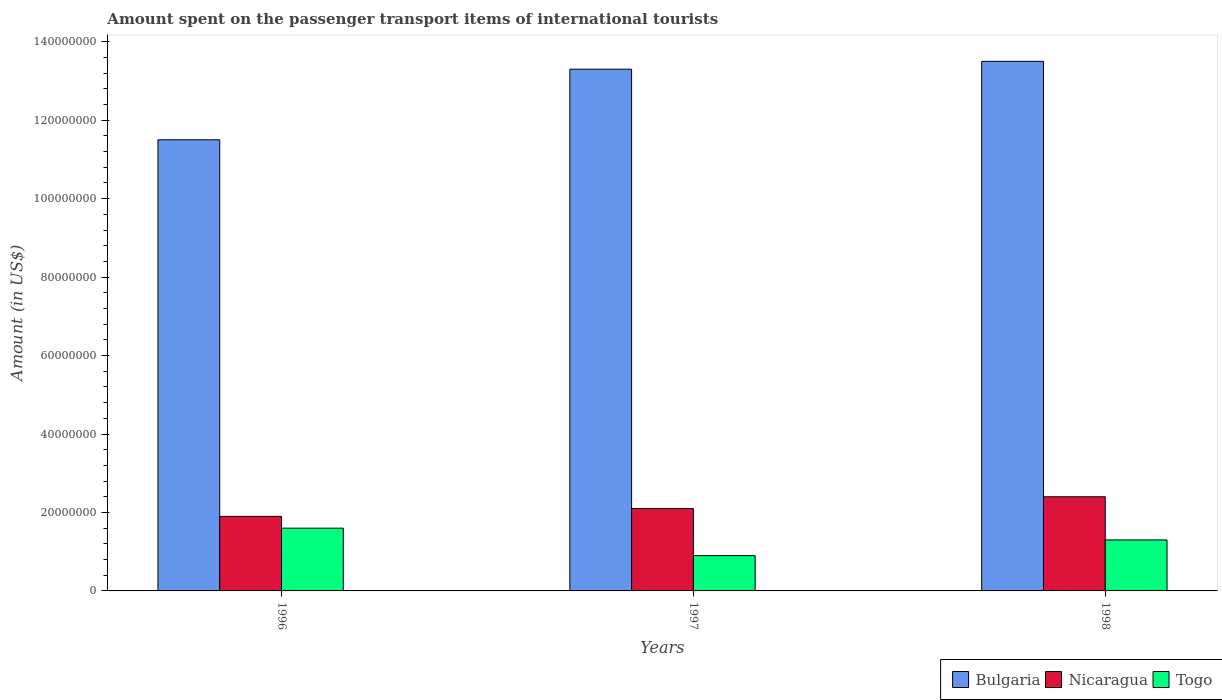How many different coloured bars are there?
Your answer should be very brief. 3. How many groups of bars are there?
Offer a terse response. 3. Are the number of bars per tick equal to the number of legend labels?
Offer a terse response. Yes. Are the number of bars on each tick of the X-axis equal?
Make the answer very short. Yes. In how many cases, is the number of bars for a given year not equal to the number of legend labels?
Your answer should be compact. 0. What is the amount spent on the passenger transport items of international tourists in Bulgaria in 1996?
Your answer should be very brief. 1.15e+08. Across all years, what is the maximum amount spent on the passenger transport items of international tourists in Nicaragua?
Provide a short and direct response. 2.40e+07. Across all years, what is the minimum amount spent on the passenger transport items of international tourists in Togo?
Your response must be concise. 9.00e+06. In which year was the amount spent on the passenger transport items of international tourists in Nicaragua minimum?
Offer a very short reply. 1996. What is the total amount spent on the passenger transport items of international tourists in Nicaragua in the graph?
Your answer should be compact. 6.40e+07. What is the difference between the amount spent on the passenger transport items of international tourists in Bulgaria in 1996 and that in 1998?
Provide a succinct answer. -2.00e+07. What is the difference between the amount spent on the passenger transport items of international tourists in Togo in 1998 and the amount spent on the passenger transport items of international tourists in Nicaragua in 1996?
Your response must be concise. -6.00e+06. What is the average amount spent on the passenger transport items of international tourists in Togo per year?
Offer a terse response. 1.27e+07. In the year 1998, what is the difference between the amount spent on the passenger transport items of international tourists in Bulgaria and amount spent on the passenger transport items of international tourists in Togo?
Offer a very short reply. 1.22e+08. In how many years, is the amount spent on the passenger transport items of international tourists in Togo greater than 128000000 US$?
Offer a terse response. 0. What is the ratio of the amount spent on the passenger transport items of international tourists in Nicaragua in 1996 to that in 1998?
Give a very brief answer. 0.79. What is the difference between the highest and the second highest amount spent on the passenger transport items of international tourists in Nicaragua?
Provide a succinct answer. 3.00e+06. What is the difference between the highest and the lowest amount spent on the passenger transport items of international tourists in Nicaragua?
Your answer should be very brief. 5.00e+06. What does the 1st bar from the left in 1998 represents?
Provide a succinct answer. Bulgaria. What does the 2nd bar from the right in 1996 represents?
Your answer should be compact. Nicaragua. Is it the case that in every year, the sum of the amount spent on the passenger transport items of international tourists in Nicaragua and amount spent on the passenger transport items of international tourists in Togo is greater than the amount spent on the passenger transport items of international tourists in Bulgaria?
Make the answer very short. No. Are all the bars in the graph horizontal?
Ensure brevity in your answer.  No. What is the difference between two consecutive major ticks on the Y-axis?
Offer a terse response. 2.00e+07. Where does the legend appear in the graph?
Your answer should be compact. Bottom right. What is the title of the graph?
Offer a very short reply. Amount spent on the passenger transport items of international tourists. What is the label or title of the X-axis?
Offer a terse response. Years. What is the Amount (in US$) of Bulgaria in 1996?
Keep it short and to the point. 1.15e+08. What is the Amount (in US$) of Nicaragua in 1996?
Provide a short and direct response. 1.90e+07. What is the Amount (in US$) in Togo in 1996?
Provide a short and direct response. 1.60e+07. What is the Amount (in US$) of Bulgaria in 1997?
Keep it short and to the point. 1.33e+08. What is the Amount (in US$) of Nicaragua in 1997?
Give a very brief answer. 2.10e+07. What is the Amount (in US$) of Togo in 1997?
Provide a succinct answer. 9.00e+06. What is the Amount (in US$) in Bulgaria in 1998?
Give a very brief answer. 1.35e+08. What is the Amount (in US$) of Nicaragua in 1998?
Your response must be concise. 2.40e+07. What is the Amount (in US$) in Togo in 1998?
Provide a succinct answer. 1.30e+07. Across all years, what is the maximum Amount (in US$) of Bulgaria?
Your response must be concise. 1.35e+08. Across all years, what is the maximum Amount (in US$) of Nicaragua?
Your answer should be compact. 2.40e+07. Across all years, what is the maximum Amount (in US$) of Togo?
Your answer should be very brief. 1.60e+07. Across all years, what is the minimum Amount (in US$) in Bulgaria?
Your response must be concise. 1.15e+08. Across all years, what is the minimum Amount (in US$) of Nicaragua?
Provide a short and direct response. 1.90e+07. Across all years, what is the minimum Amount (in US$) in Togo?
Your answer should be compact. 9.00e+06. What is the total Amount (in US$) of Bulgaria in the graph?
Provide a short and direct response. 3.83e+08. What is the total Amount (in US$) of Nicaragua in the graph?
Make the answer very short. 6.40e+07. What is the total Amount (in US$) in Togo in the graph?
Your response must be concise. 3.80e+07. What is the difference between the Amount (in US$) of Bulgaria in 1996 and that in 1997?
Give a very brief answer. -1.80e+07. What is the difference between the Amount (in US$) of Togo in 1996 and that in 1997?
Your answer should be compact. 7.00e+06. What is the difference between the Amount (in US$) in Bulgaria in 1996 and that in 1998?
Make the answer very short. -2.00e+07. What is the difference between the Amount (in US$) in Nicaragua in 1996 and that in 1998?
Provide a succinct answer. -5.00e+06. What is the difference between the Amount (in US$) in Togo in 1996 and that in 1998?
Give a very brief answer. 3.00e+06. What is the difference between the Amount (in US$) in Togo in 1997 and that in 1998?
Give a very brief answer. -4.00e+06. What is the difference between the Amount (in US$) in Bulgaria in 1996 and the Amount (in US$) in Nicaragua in 1997?
Make the answer very short. 9.40e+07. What is the difference between the Amount (in US$) in Bulgaria in 1996 and the Amount (in US$) in Togo in 1997?
Make the answer very short. 1.06e+08. What is the difference between the Amount (in US$) in Nicaragua in 1996 and the Amount (in US$) in Togo in 1997?
Offer a very short reply. 1.00e+07. What is the difference between the Amount (in US$) in Bulgaria in 1996 and the Amount (in US$) in Nicaragua in 1998?
Provide a short and direct response. 9.10e+07. What is the difference between the Amount (in US$) of Bulgaria in 1996 and the Amount (in US$) of Togo in 1998?
Your response must be concise. 1.02e+08. What is the difference between the Amount (in US$) in Nicaragua in 1996 and the Amount (in US$) in Togo in 1998?
Provide a succinct answer. 6.00e+06. What is the difference between the Amount (in US$) of Bulgaria in 1997 and the Amount (in US$) of Nicaragua in 1998?
Your answer should be very brief. 1.09e+08. What is the difference between the Amount (in US$) of Bulgaria in 1997 and the Amount (in US$) of Togo in 1998?
Offer a very short reply. 1.20e+08. What is the difference between the Amount (in US$) of Nicaragua in 1997 and the Amount (in US$) of Togo in 1998?
Give a very brief answer. 8.00e+06. What is the average Amount (in US$) in Bulgaria per year?
Provide a succinct answer. 1.28e+08. What is the average Amount (in US$) in Nicaragua per year?
Offer a very short reply. 2.13e+07. What is the average Amount (in US$) of Togo per year?
Your answer should be very brief. 1.27e+07. In the year 1996, what is the difference between the Amount (in US$) in Bulgaria and Amount (in US$) in Nicaragua?
Provide a succinct answer. 9.60e+07. In the year 1996, what is the difference between the Amount (in US$) of Bulgaria and Amount (in US$) of Togo?
Offer a terse response. 9.90e+07. In the year 1996, what is the difference between the Amount (in US$) of Nicaragua and Amount (in US$) of Togo?
Make the answer very short. 3.00e+06. In the year 1997, what is the difference between the Amount (in US$) of Bulgaria and Amount (in US$) of Nicaragua?
Give a very brief answer. 1.12e+08. In the year 1997, what is the difference between the Amount (in US$) in Bulgaria and Amount (in US$) in Togo?
Your answer should be compact. 1.24e+08. In the year 1997, what is the difference between the Amount (in US$) of Nicaragua and Amount (in US$) of Togo?
Give a very brief answer. 1.20e+07. In the year 1998, what is the difference between the Amount (in US$) in Bulgaria and Amount (in US$) in Nicaragua?
Provide a succinct answer. 1.11e+08. In the year 1998, what is the difference between the Amount (in US$) of Bulgaria and Amount (in US$) of Togo?
Provide a succinct answer. 1.22e+08. In the year 1998, what is the difference between the Amount (in US$) of Nicaragua and Amount (in US$) of Togo?
Keep it short and to the point. 1.10e+07. What is the ratio of the Amount (in US$) of Bulgaria in 1996 to that in 1997?
Your answer should be compact. 0.86. What is the ratio of the Amount (in US$) in Nicaragua in 1996 to that in 1997?
Give a very brief answer. 0.9. What is the ratio of the Amount (in US$) of Togo in 1996 to that in 1997?
Provide a short and direct response. 1.78. What is the ratio of the Amount (in US$) of Bulgaria in 1996 to that in 1998?
Ensure brevity in your answer.  0.85. What is the ratio of the Amount (in US$) of Nicaragua in 1996 to that in 1998?
Keep it short and to the point. 0.79. What is the ratio of the Amount (in US$) in Togo in 1996 to that in 1998?
Keep it short and to the point. 1.23. What is the ratio of the Amount (in US$) of Bulgaria in 1997 to that in 1998?
Make the answer very short. 0.99. What is the ratio of the Amount (in US$) of Togo in 1997 to that in 1998?
Your answer should be very brief. 0.69. What is the difference between the highest and the second highest Amount (in US$) in Bulgaria?
Keep it short and to the point. 2.00e+06. What is the difference between the highest and the second highest Amount (in US$) of Togo?
Your answer should be compact. 3.00e+06. What is the difference between the highest and the lowest Amount (in US$) of Bulgaria?
Make the answer very short. 2.00e+07. What is the difference between the highest and the lowest Amount (in US$) of Togo?
Offer a very short reply. 7.00e+06. 